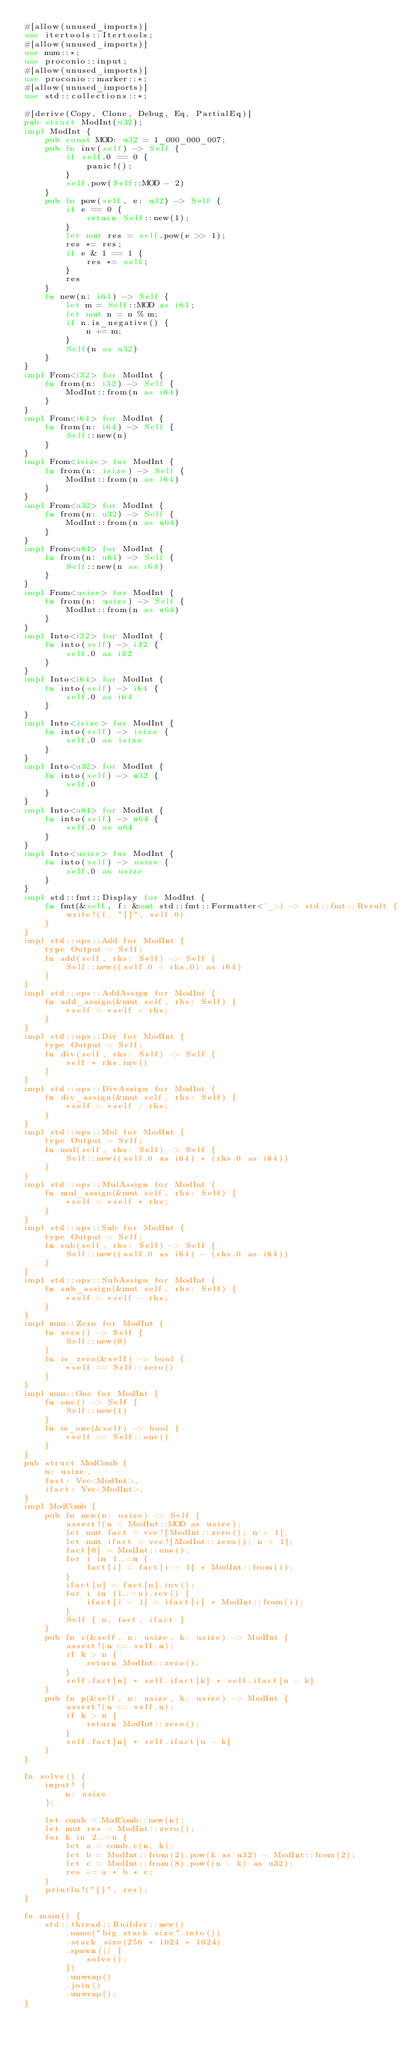Convert code to text. <code><loc_0><loc_0><loc_500><loc_500><_Rust_>#[allow(unused_imports)]
use itertools::Itertools;
#[allow(unused_imports)]
use num::*;
use proconio::input;
#[allow(unused_imports)]
use proconio::marker::*;
#[allow(unused_imports)]
use std::collections::*;

#[derive(Copy, Clone, Debug, Eq, PartialEq)]
pub struct ModInt(u32);
impl ModInt {
    pub const MOD: u32 = 1_000_000_007;
    pub fn inv(self) -> Self {
        if self.0 == 0 {
            panic!();
        }
        self.pow(Self::MOD - 2)
    }
    pub fn pow(self, e: u32) -> Self {
        if e == 0 {
            return Self::new(1);
        }
        let mut res = self.pow(e >> 1);
        res *= res;
        if e & 1 == 1 {
            res *= self;
        }
        res
    }
    fn new(n: i64) -> Self {
        let m = Self::MOD as i64;
        let mut n = n % m;
        if n.is_negative() {
            n += m;
        }
        Self(n as u32)
    }
}
impl From<i32> for ModInt {
    fn from(n: i32) -> Self {
        ModInt::from(n as i64)
    }
}
impl From<i64> for ModInt {
    fn from(n: i64) -> Self {
        Self::new(n)
    }
}
impl From<isize> for ModInt {
    fn from(n: isize) -> Self {
        ModInt::from(n as i64)
    }
}
impl From<u32> for ModInt {
    fn from(n: u32) -> Self {
        ModInt::from(n as u64)
    }
}
impl From<u64> for ModInt {
    fn from(n: u64) -> Self {
        Self::new(n as i64)
    }
}
impl From<usize> for ModInt {
    fn from(n: usize) -> Self {
        ModInt::from(n as u64)
    }
}
impl Into<i32> for ModInt {
    fn into(self) -> i32 {
        self.0 as i32
    }
}
impl Into<i64> for ModInt {
    fn into(self) -> i64 {
        self.0 as i64
    }
}
impl Into<isize> for ModInt {
    fn into(self) -> isize {
        self.0 as isize
    }
}
impl Into<u32> for ModInt {
    fn into(self) -> u32 {
        self.0
    }
}
impl Into<u64> for ModInt {
    fn into(self) -> u64 {
        self.0 as u64
    }
}
impl Into<usize> for ModInt {
    fn into(self) -> usize {
        self.0 as usize
    }
}
impl std::fmt::Display for ModInt {
    fn fmt(&self, f: &mut std::fmt::Formatter<'_>) -> std::fmt::Result {
        write!(f, "{}", self.0)
    }
}
impl std::ops::Add for ModInt {
    type Output = Self;
    fn add(self, rhs: Self) -> Self {
        Self::new((self.0 + rhs.0) as i64)
    }
}
impl std::ops::AddAssign for ModInt {
    fn add_assign(&mut self, rhs: Self) {
        *self = *self + rhs;
    }
}
impl std::ops::Div for ModInt {
    type Output = Self;
    fn div(self, rhs: Self) -> Self {
        self * rhs.inv()
    }
}
impl std::ops::DivAssign for ModInt {
    fn div_assign(&mut self, rhs: Self) {
        *self = *self / rhs;
    }
}
impl std::ops::Mul for ModInt {
    type Output = Self;
    fn mul(self, rhs: Self) -> Self {
        Self::new((self.0 as i64) * (rhs.0 as i64))
    }
}
impl std::ops::MulAssign for ModInt {
    fn mul_assign(&mut self, rhs: Self) {
        *self = *self * rhs;
    }
}
impl std::ops::Sub for ModInt {
    type Output = Self;
    fn sub(self, rhs: Self) -> Self {
        Self::new((self.0 as i64) - (rhs.0 as i64))
    }
}
impl std::ops::SubAssign for ModInt {
    fn sub_assign(&mut self, rhs: Self) {
        *self = *self - rhs;
    }
}
impl num::Zero for ModInt {
    fn zero() -> Self {
        Self::new(0)
    }
    fn is_zero(&self) -> bool {
        *self == Self::zero()
    }
}
impl num::One for ModInt {
    fn one() -> Self {
        Self::new(1)
    }
    fn is_one(&self) -> bool {
        *self == Self::one()
    }
}
pub struct ModComb {
    n: usize,
    fact: Vec<ModInt>,
    ifact: Vec<ModInt>,
}
impl ModComb {
    pub fn new(n: usize) -> Self {
        assert!(n < ModInt::MOD as usize);
        let mut fact = vec![ModInt::zero(); n + 1];
        let mut ifact = vec![ModInt::zero(); n + 1];
        fact[0] = ModInt::one();
        for i in 1..=n {
            fact[i] = fact[i - 1] * ModInt::from(i);
        }
        ifact[n] = fact[n].inv();
        for i in (1..=n).rev() {
            ifact[i - 1] = ifact[i] * ModInt::from(i);
        }
        Self { n, fact, ifact }
    }
    pub fn c(&self, n: usize, k: usize) -> ModInt {
        assert!(n <= self.n);
        if k > n {
            return ModInt::zero();
        }
        self.fact[n] * self.ifact[k] * self.ifact[n - k]
    }
    pub fn p(&self, n: usize, k: usize) -> ModInt {
        assert!(n <= self.n);
        if k > n {
            return ModInt::zero();
        }
        self.fact[n] * self.ifact[n - k]
    }
}

fn solve() {
    input! {
        n: usize
    };

    let comb = ModComb::new(n);
    let mut res = ModInt::zero();
    for k in 2..=n {
        let a = comb.c(n, k);
        let b = ModInt::from(2).pow(k as u32) - ModInt::from(2);
        let c = ModInt::from(8).pow((n - k) as u32);
        res += a * b * c;
    }
    println!("{}", res);
}

fn main() {
    std::thread::Builder::new()
        .name("big stack size".into())
        .stack_size(256 * 1024 * 1024)
        .spawn(|| {
            solve();
        })
        .unwrap()
        .join()
        .unwrap();
}
</code> 